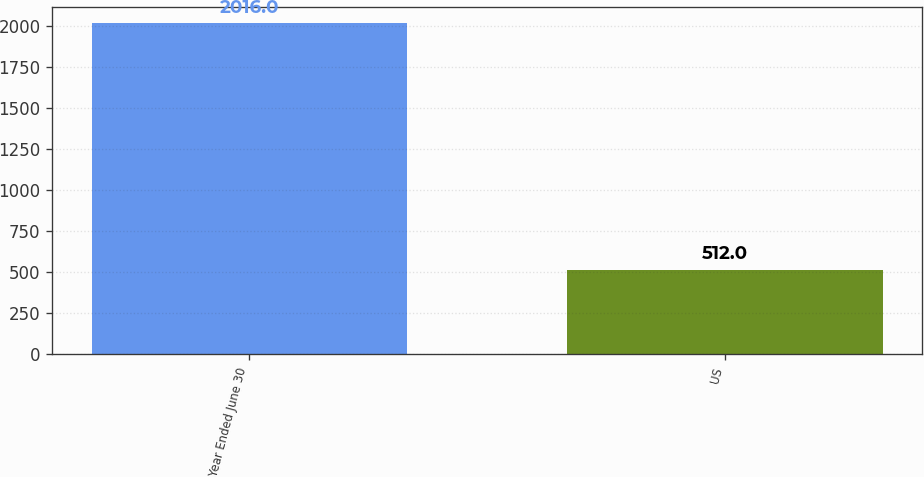Convert chart to OTSL. <chart><loc_0><loc_0><loc_500><loc_500><bar_chart><fcel>Year Ended June 30<fcel>US<nl><fcel>2016<fcel>512<nl></chart> 